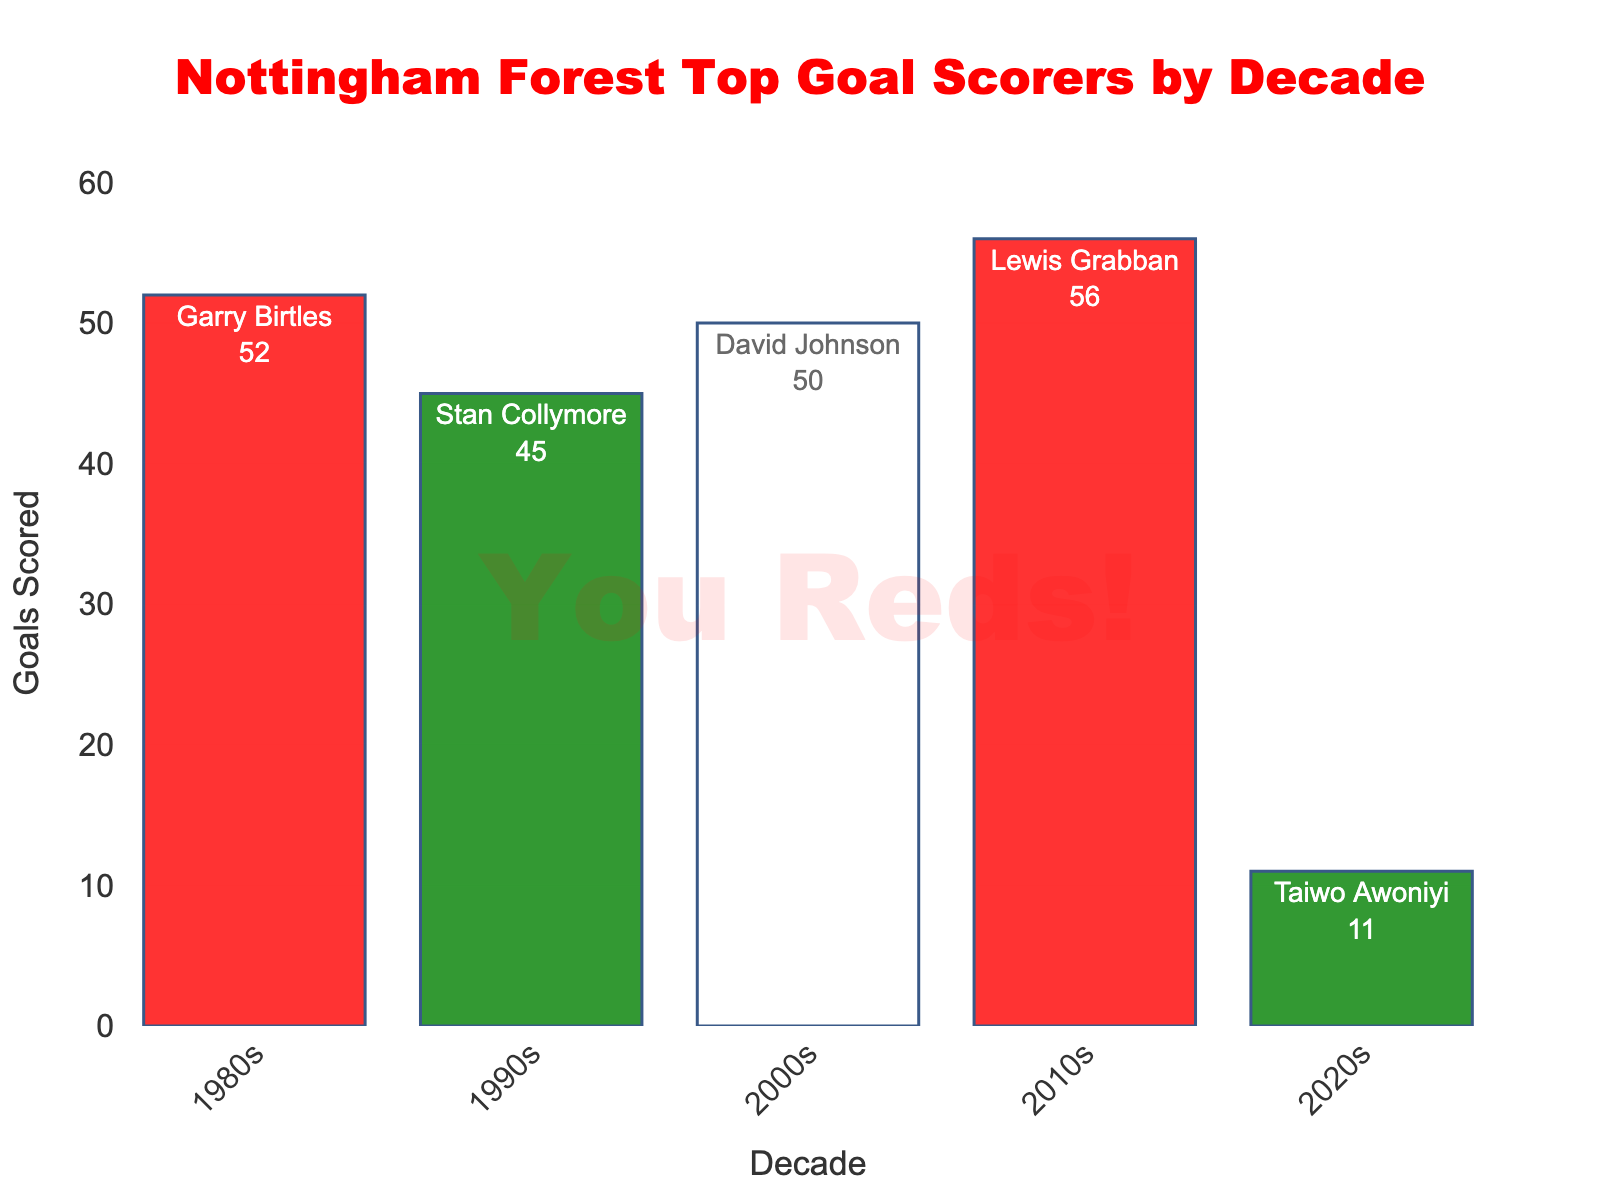Who was the top scorer for Nottingham Forest in the 1990s? Look at the bar labeled "1990s". The text inside the bar shows both the top scorer and the number of goals.
Answer: Stan Collymore How many goals did Lewis Grabban score in the 2010s? Refer to the bar labeled "2010s" and check the text inside it, which shows the name and number of goals.
Answer: 56 Which decade saw the highest number of goals scored by the top scorer? Examine the heights of all the bars and identify which bar is the tallest, representing the highest number of goals scored.
Answer: 2010s Who scored more goals: Garry Birtles in the 1980s or David Johnson in the 2000s? Compare the heights of the bars for the 1980s and 2000s, or look at the text inside these bars. Garry Birtles scored 52 goals and David Johnson scored 50.
Answer: Garry Birtles What is the total number of goals scored by the top scorers across all decades? Add up the goals from each decade: 52 (1980s) + 45 (1990s) + 50 (2000s) + 56 (2010s) + 11 (2020s) = 214.
Answer: 214 Who is the top scorer with the least number of goals, and in which decade did he play? Identify the shortest bar and refer to the text inside it to find out the player and the decade.
Answer: Taiwo Awoniyi, 2020s What is the average number of goals scored by the top scorer per decade? Sum the total goals and divide by the number of decades: (52+45+50+56+11)/5 = 214/5 = 42.8.
Answer: 42.8 Is the number of goals scored by Taiwo Awoniyi in the 2020s more than half of those scored by Stan Collymore in the 1990s? Compare half of Stan Collymore's goals (45/2 = 22.5) to Taiwo Awoniyi's goals (11).
Answer: No Between the 1980s and 2010s, how much more are the goals scored by the top scorer of the 2010s? Subtract Garry Birtles' goals (52) from Lewis Grabban's goals (56): 56 - 52 = 4.
Answer: 4 Which two decades have top scorers with goals whose difference is the largest, and what is the difference? Find the difference between each pair of decades and identify the largest difference: 56 (2010s) - 11 (2020s) = 45.
Answer: 2010s and 2020s, 45 